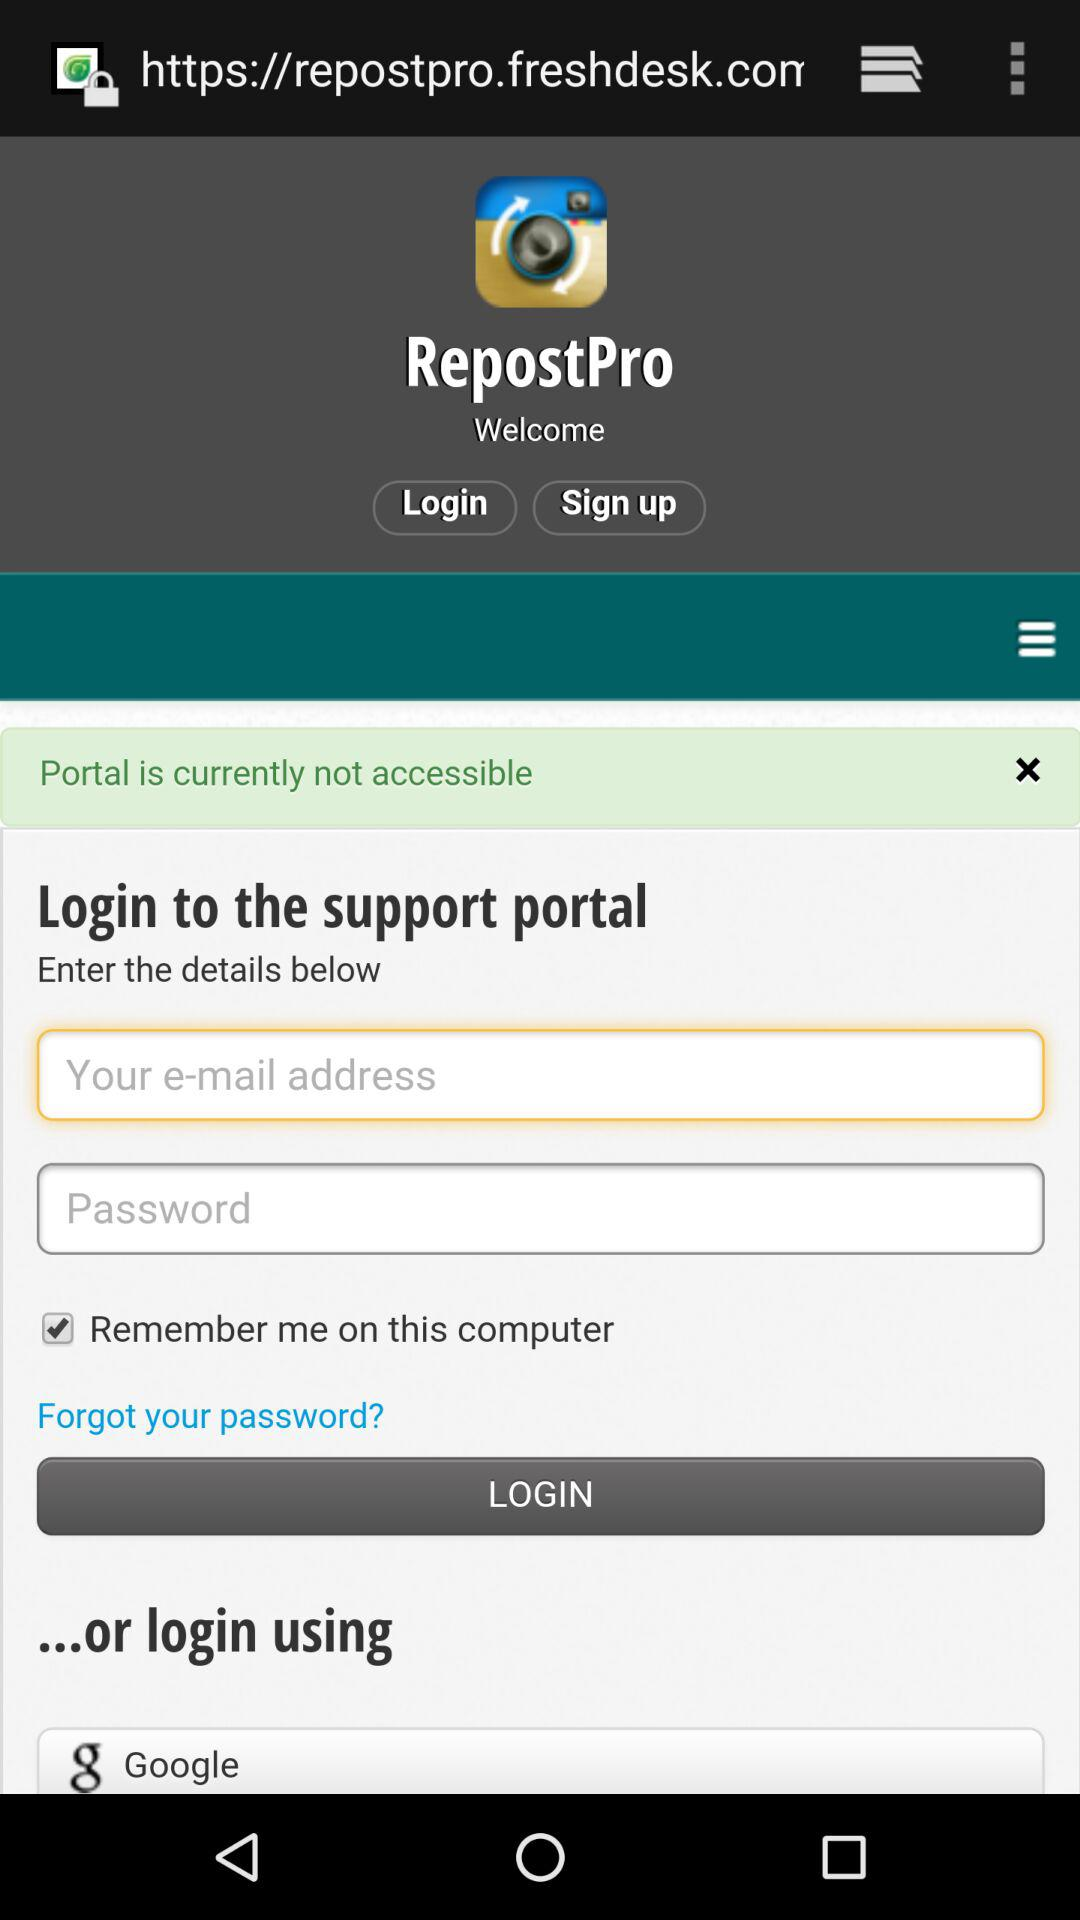What other applications can be used to log in? The application that can be used to log in is "Google". 